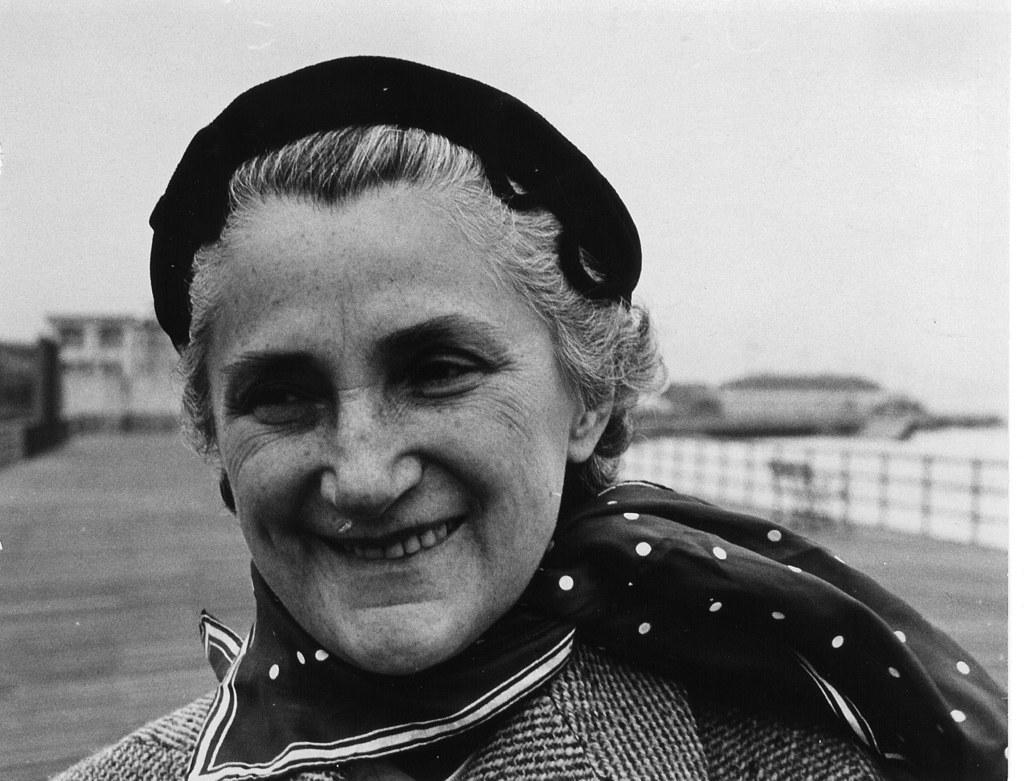Can you describe this image briefly? It is a black and white image, in the foreground there is a woman and the background of the woman is blur. 